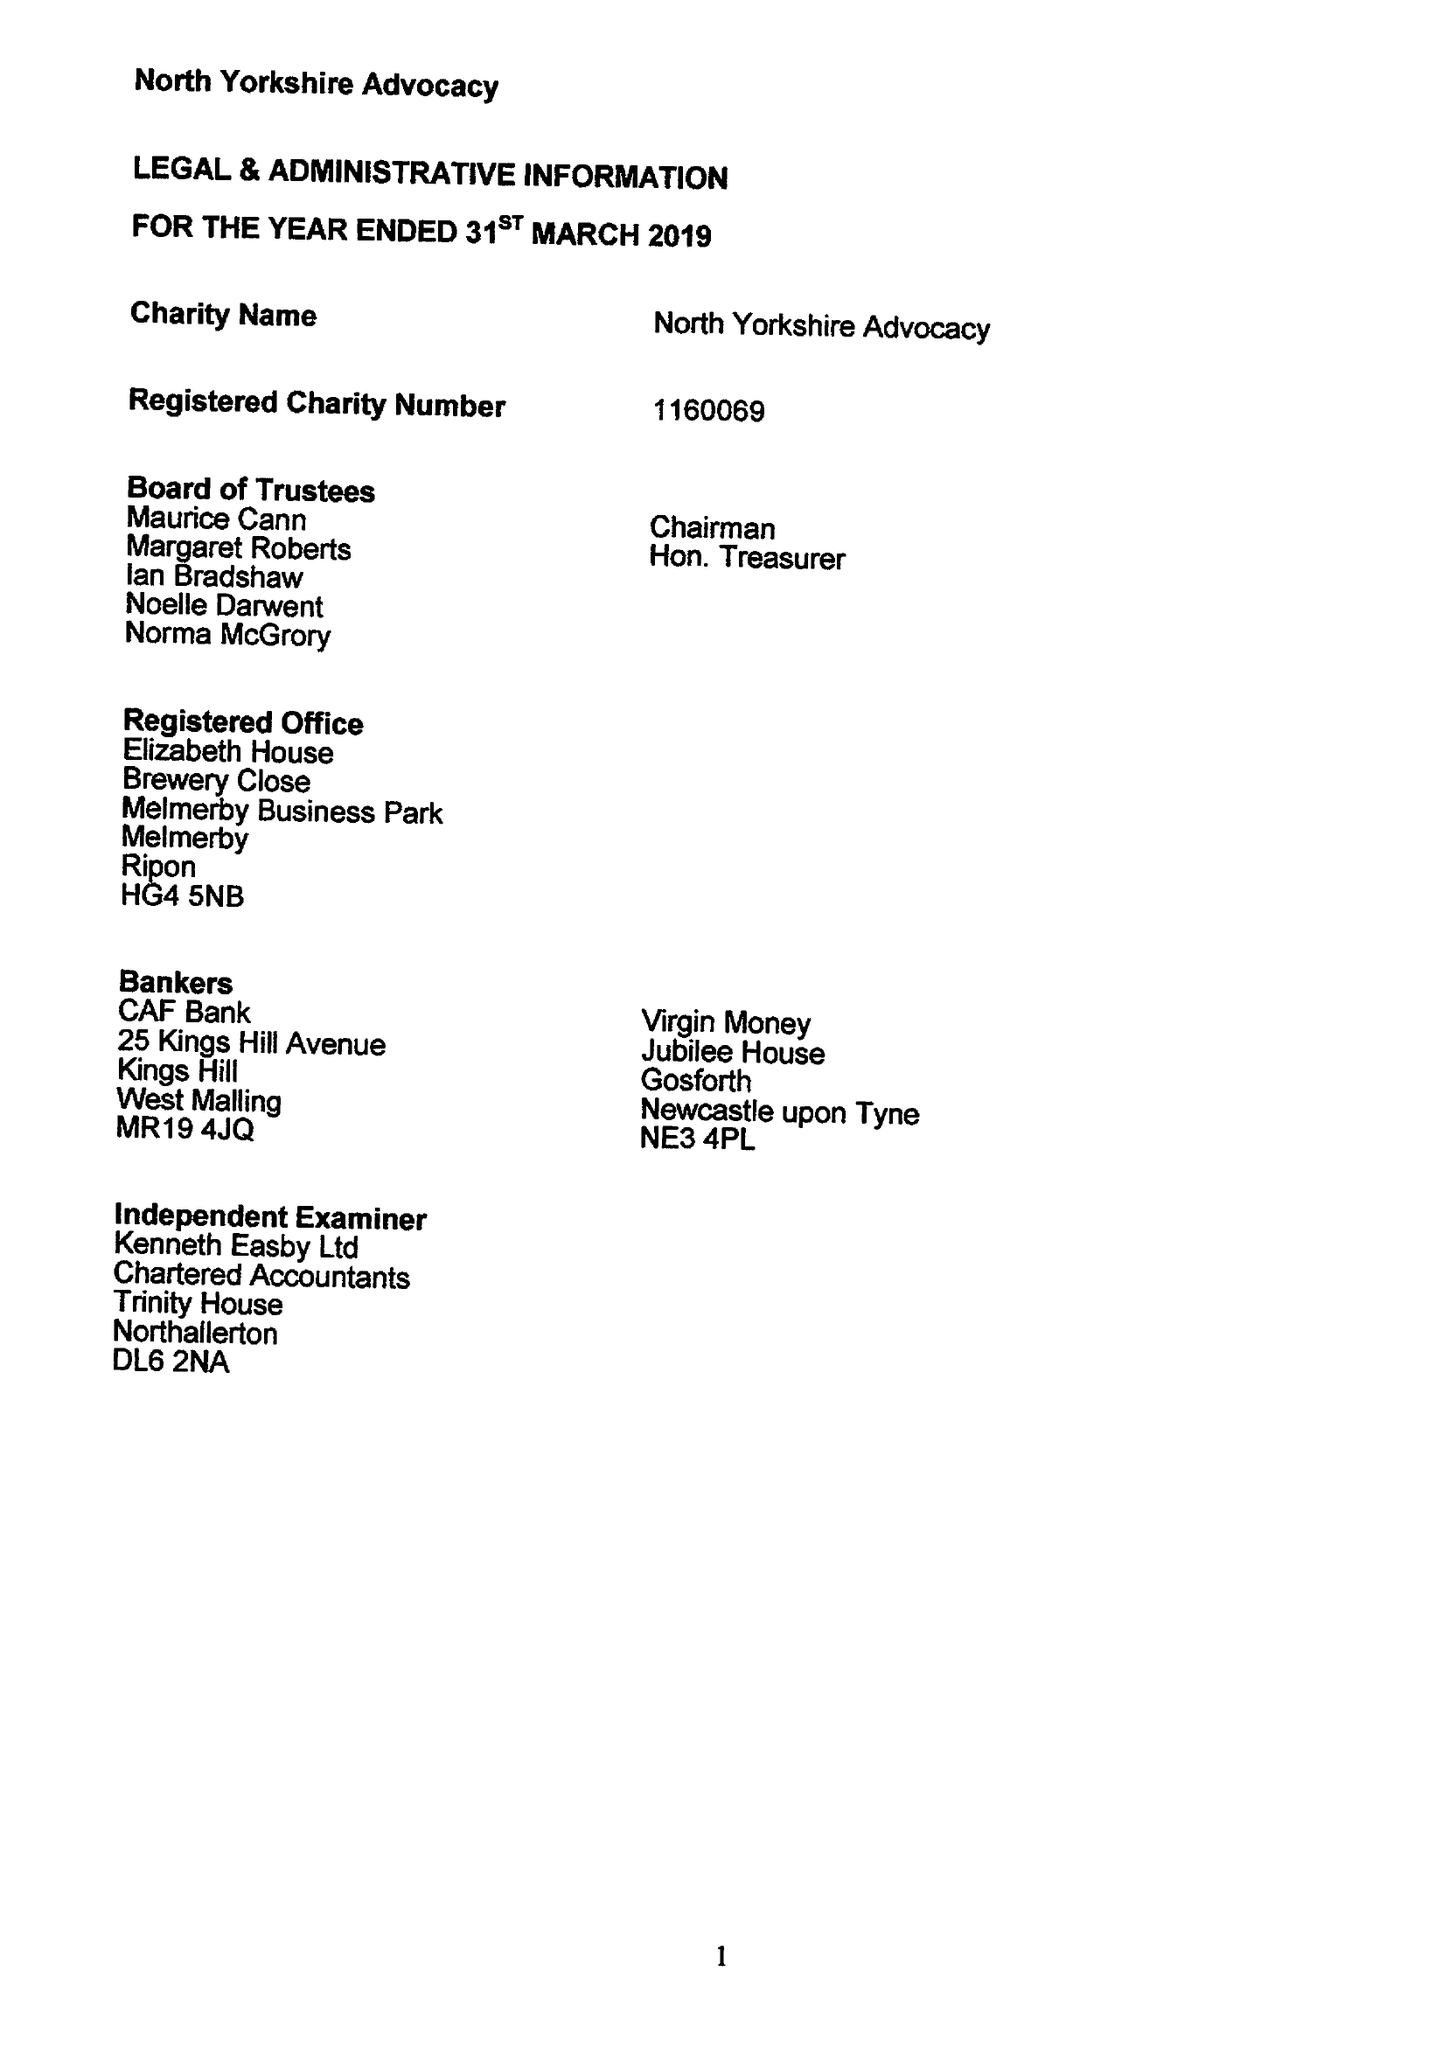What is the value for the charity_number?
Answer the question using a single word or phrase. 1160069 